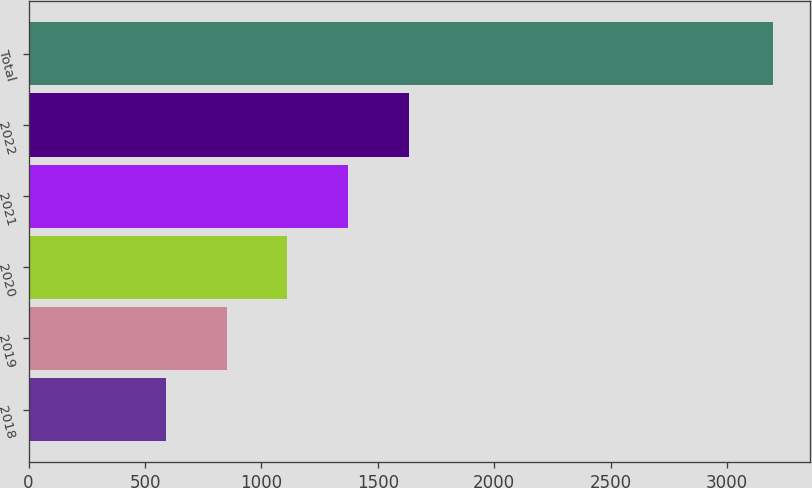Convert chart to OTSL. <chart><loc_0><loc_0><loc_500><loc_500><bar_chart><fcel>2018<fcel>2019<fcel>2020<fcel>2021<fcel>2022<fcel>Total<nl><fcel>590<fcel>850.6<fcel>1111.2<fcel>1371.8<fcel>1632.4<fcel>3196<nl></chart> 